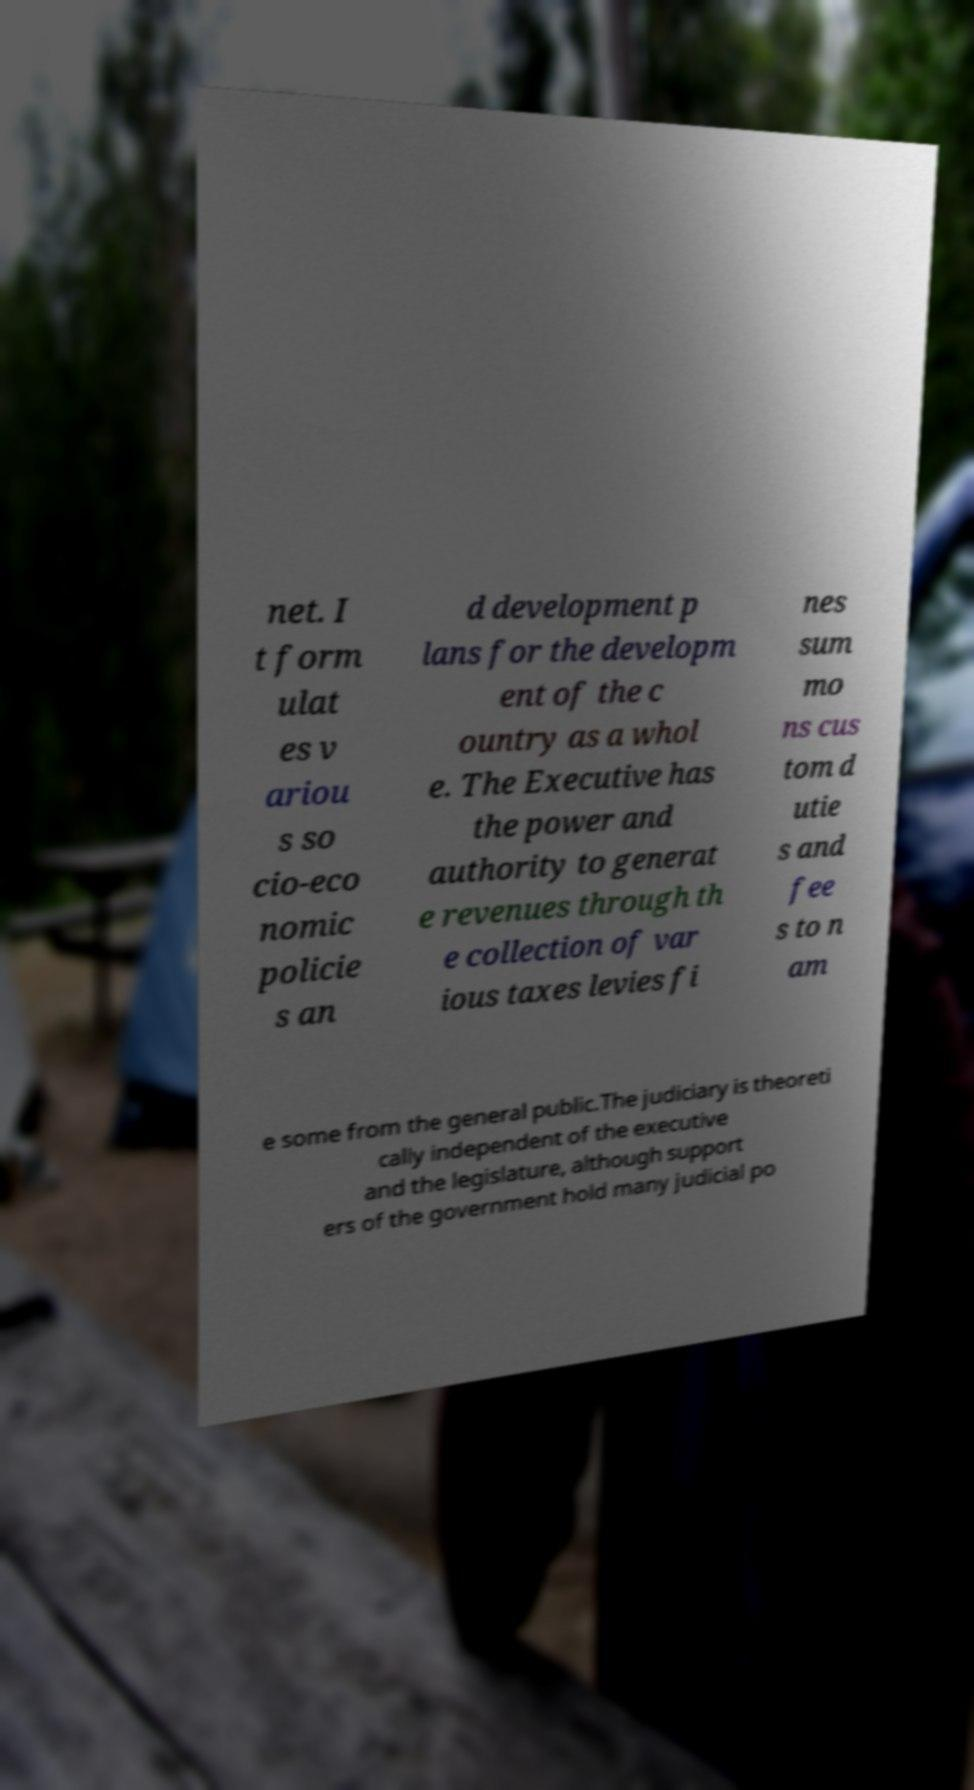Please identify and transcribe the text found in this image. net. I t form ulat es v ariou s so cio-eco nomic policie s an d development p lans for the developm ent of the c ountry as a whol e. The Executive has the power and authority to generat e revenues through th e collection of var ious taxes levies fi nes sum mo ns cus tom d utie s and fee s to n am e some from the general public.The judiciary is theoreti cally independent of the executive and the legislature, although support ers of the government hold many judicial po 